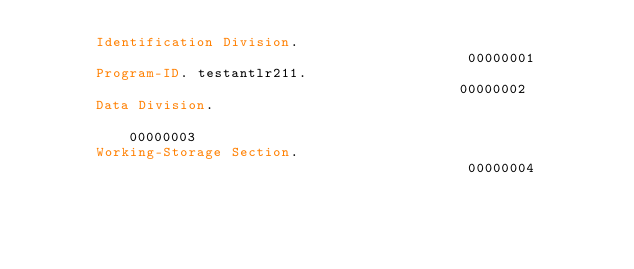<code> <loc_0><loc_0><loc_500><loc_500><_COBOL_>       Identification Division.                                         00000001
       Program-ID. testantlr211.                                        00000002
       Data Division.                                                   00000003
       Working-Storage Section.                                         00000004
                                                                        00000005</code> 